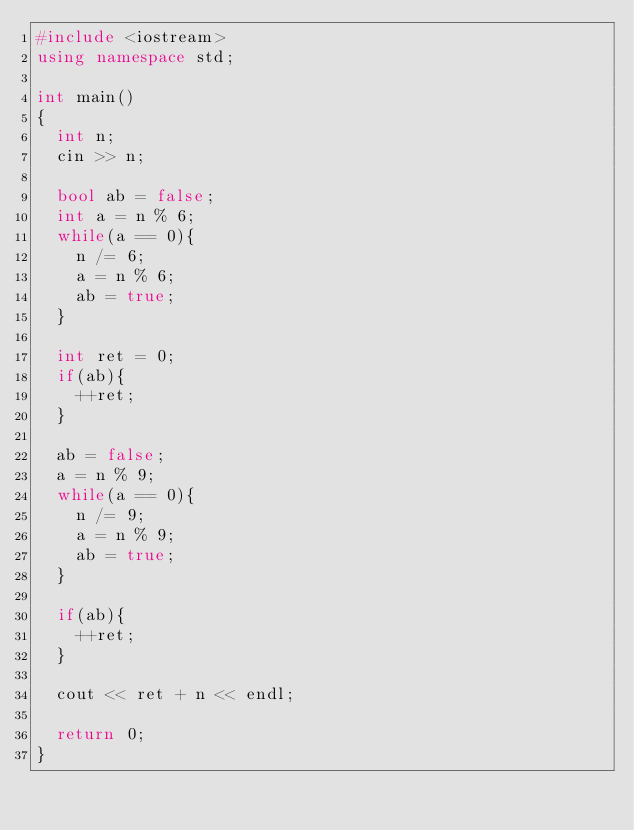<code> <loc_0><loc_0><loc_500><loc_500><_C++_>#include <iostream>
using namespace std;

int main()
{
  int n;
  cin >> n;
  
  bool ab = false;
  int a = n % 6;
  while(a == 0){
    n /= 6;
    a = n % 6;
    ab = true;
  }
  
  int ret = 0;
  if(ab){
    ++ret;
  }
  
  ab = false;
  a = n % 9;
  while(a == 0){
    n /= 9;
    a = n % 9;
    ab = true;
  }

  if(ab){
    ++ret;
  }

  cout << ret + n << endl;
  
  return 0;
}</code> 